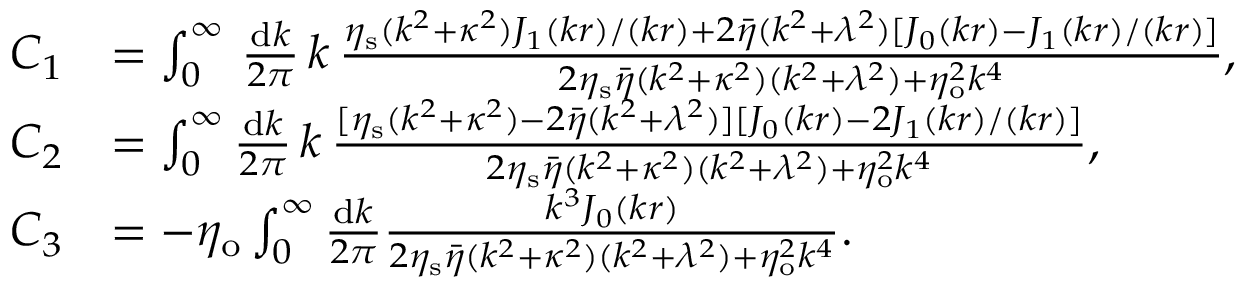<formula> <loc_0><loc_0><loc_500><loc_500>\begin{array} { r l } { C _ { 1 } } & { = \int _ { 0 } ^ { \infty } \, \frac { d k } { 2 \pi } \, k \, \frac { \eta _ { s } ( k ^ { 2 } + \kappa ^ { 2 } ) J _ { 1 } ( k r ) / ( k r ) + 2 \bar { \eta } ( k ^ { 2 } + \lambda ^ { 2 } ) [ J _ { 0 } ( k r ) - J _ { 1 } ( k r ) / ( k r ) ] } { 2 \eta _ { s } \bar { \eta } ( k ^ { 2 } + \kappa ^ { 2 } ) ( k ^ { 2 } + \lambda ^ { 2 } ) + \eta _ { o } ^ { 2 } k ^ { 4 } } , } \\ { C _ { 2 } } & { = \int _ { 0 } ^ { \infty } \frac { d k } { 2 \pi } \, k \, \frac { [ \eta _ { s } ( k ^ { 2 } + \kappa ^ { 2 } ) - 2 \bar { \eta } ( k ^ { 2 } + \lambda ^ { 2 } ) ] [ J _ { 0 } ( k r ) - 2 J _ { 1 } ( k r ) / ( k r ) ] } { 2 \eta _ { s } \bar { \eta } ( k ^ { 2 } + \kappa ^ { 2 } ) ( k ^ { 2 } + \lambda ^ { 2 } ) + \eta _ { o } ^ { 2 } k ^ { 4 } } , } \\ { C _ { 3 } } & { = - \eta _ { o } \int _ { 0 } ^ { \infty } \frac { d k } { 2 \pi } \frac { k ^ { 3 } J _ { 0 } ( k r ) } { 2 \eta _ { s } \bar { \eta } ( k ^ { 2 } + \kappa ^ { 2 } ) ( k ^ { 2 } + \lambda ^ { 2 } ) + \eta _ { o } ^ { 2 } k ^ { 4 } } . } \end{array}</formula> 